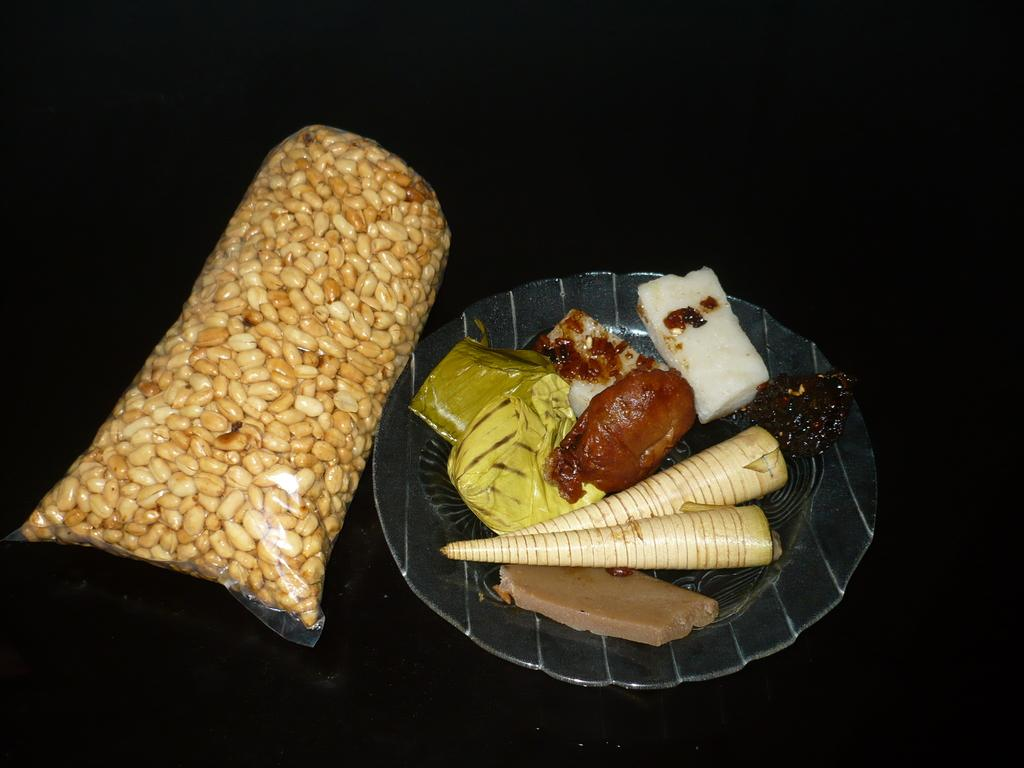What is the main object in the center of the image? There is a plate in the center of the image. What is on the plate? The plate contains pastry and chocolates. What else can be seen on the left side of the image? There is a packet of seeds on the left side of the image. What type of honey can be seen dripping from the tiger in the image? There is no tiger or honey present in the image. 